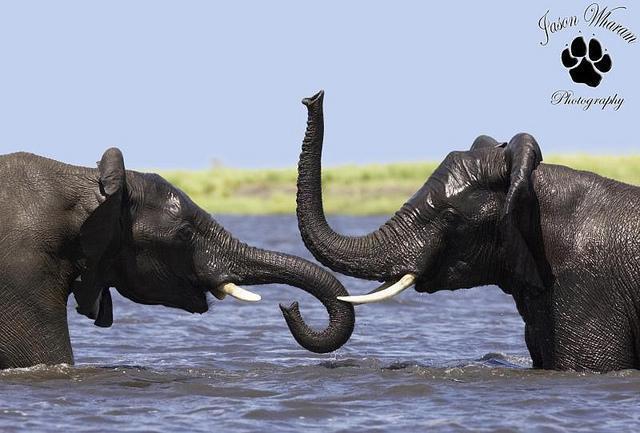How many elephants are there?
Give a very brief answer. 2. How many mice are here?
Give a very brief answer. 0. 